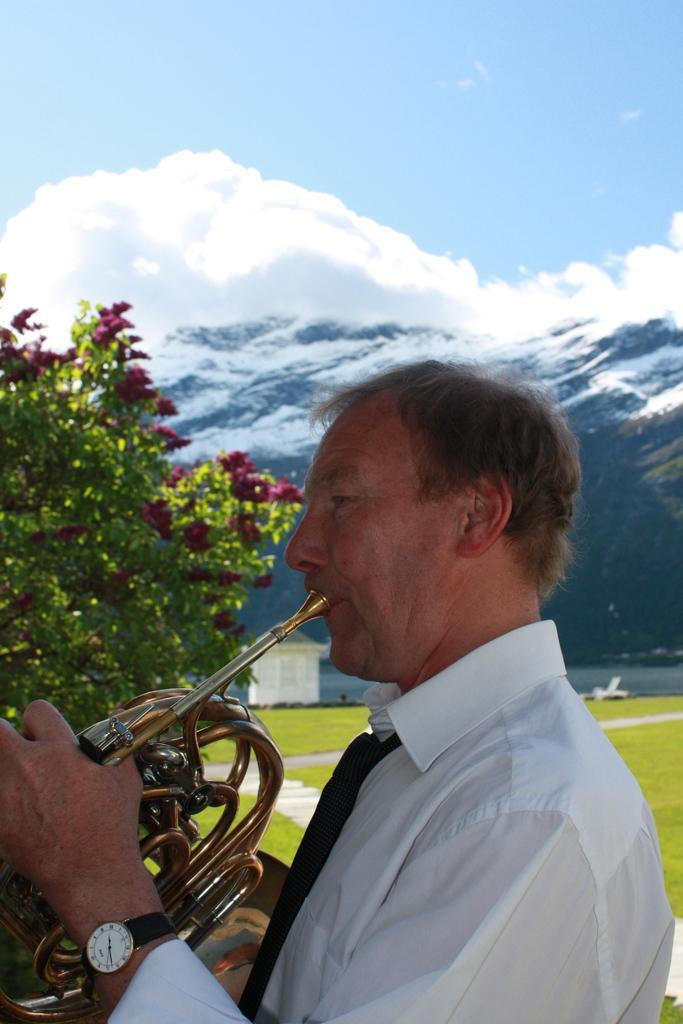Could you give a brief overview of what you see in this image? In the picture there is a man he is playing the Helicon, behind him there is a tree and behind the tree there is a grass surface and in the background there is a mountain. 